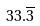Convert formula to latex. <formula><loc_0><loc_0><loc_500><loc_500>3 3 . \overline { 3 }</formula> 